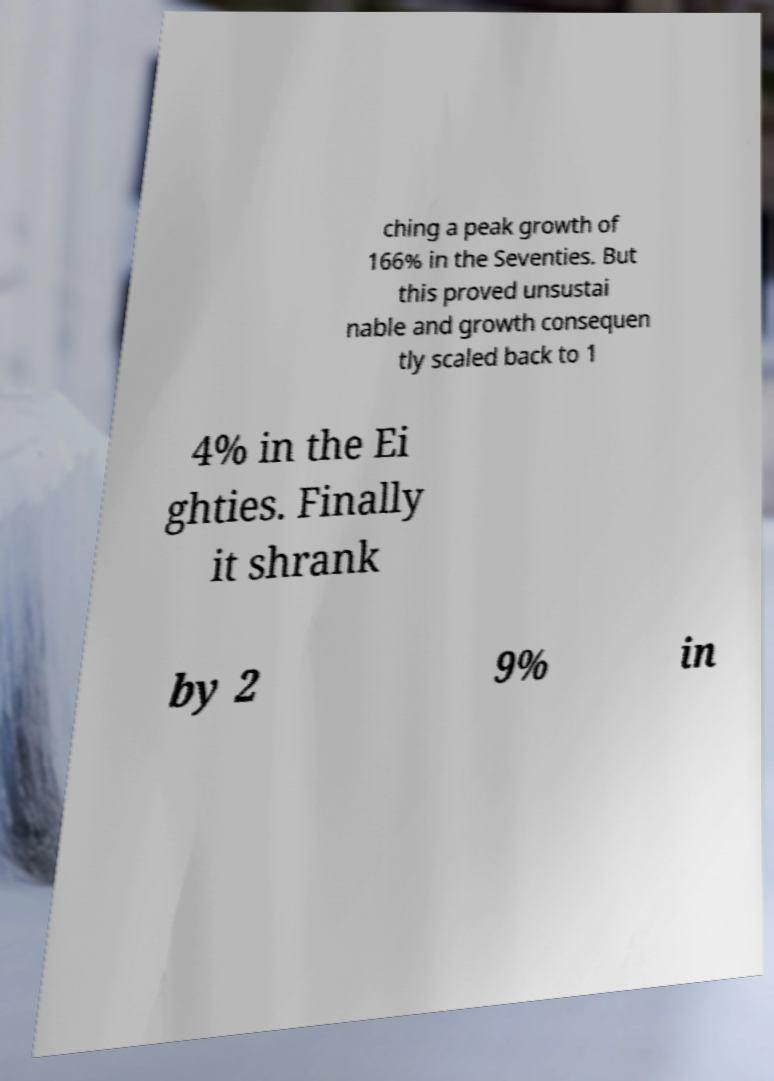Can you read and provide the text displayed in the image?This photo seems to have some interesting text. Can you extract and type it out for me? ching a peak growth of 166% in the Seventies. But this proved unsustai nable and growth consequen tly scaled back to 1 4% in the Ei ghties. Finally it shrank by 2 9% in 